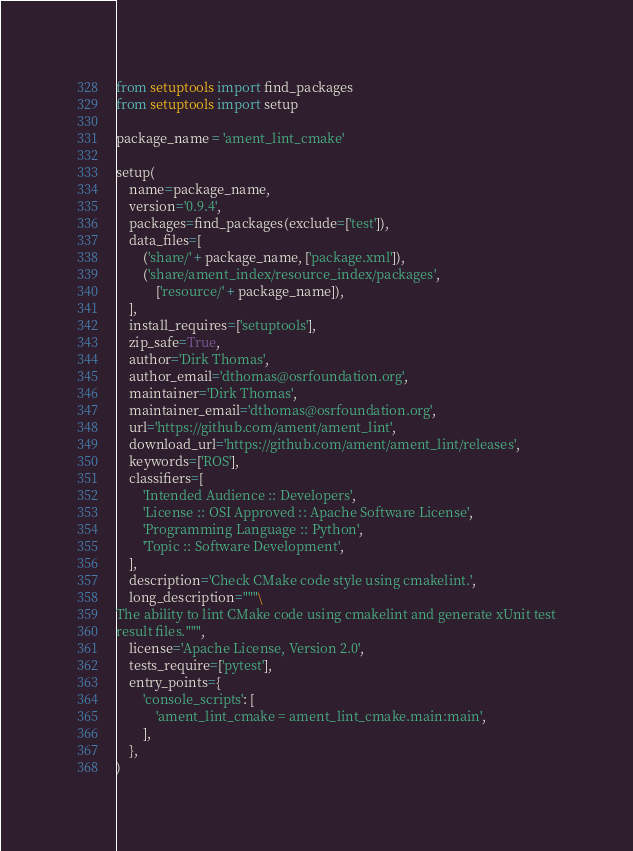<code> <loc_0><loc_0><loc_500><loc_500><_Python_>from setuptools import find_packages
from setuptools import setup

package_name = 'ament_lint_cmake'

setup(
    name=package_name,
    version='0.9.4',
    packages=find_packages(exclude=['test']),
    data_files=[
        ('share/' + package_name, ['package.xml']),
        ('share/ament_index/resource_index/packages',
            ['resource/' + package_name]),
    ],
    install_requires=['setuptools'],
    zip_safe=True,
    author='Dirk Thomas',
    author_email='dthomas@osrfoundation.org',
    maintainer='Dirk Thomas',
    maintainer_email='dthomas@osrfoundation.org',
    url='https://github.com/ament/ament_lint',
    download_url='https://github.com/ament/ament_lint/releases',
    keywords=['ROS'],
    classifiers=[
        'Intended Audience :: Developers',
        'License :: OSI Approved :: Apache Software License',
        'Programming Language :: Python',
        'Topic :: Software Development',
    ],
    description='Check CMake code style using cmakelint.',
    long_description="""\
The ability to lint CMake code using cmakelint and generate xUnit test
result files.""",
    license='Apache License, Version 2.0',
    tests_require=['pytest'],
    entry_points={
        'console_scripts': [
            'ament_lint_cmake = ament_lint_cmake.main:main',
        ],
    },
)
</code> 